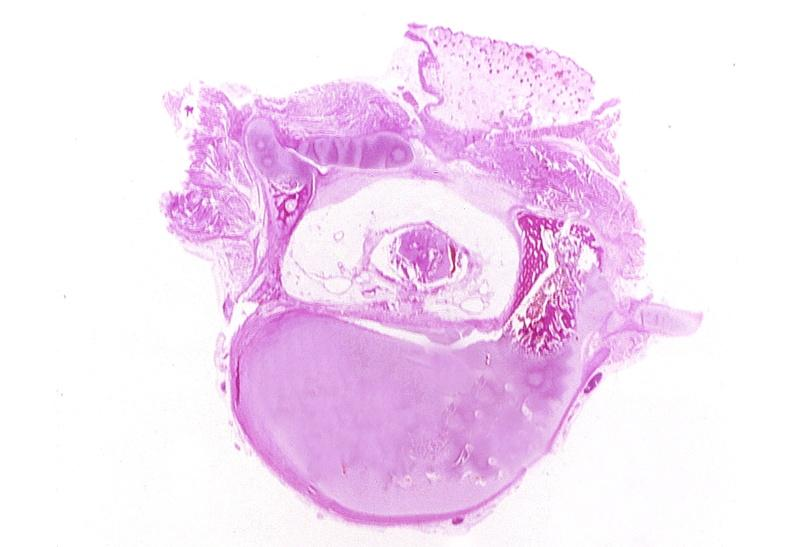does retroperitoneal liposarcoma show neural tube defect, meningomyelocele?
Answer the question using a single word or phrase. No 